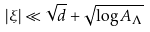Convert formula to latex. <formula><loc_0><loc_0><loc_500><loc_500>| \xi | \ll \sqrt { d } + \sqrt { \log A _ { \Lambda } }</formula> 